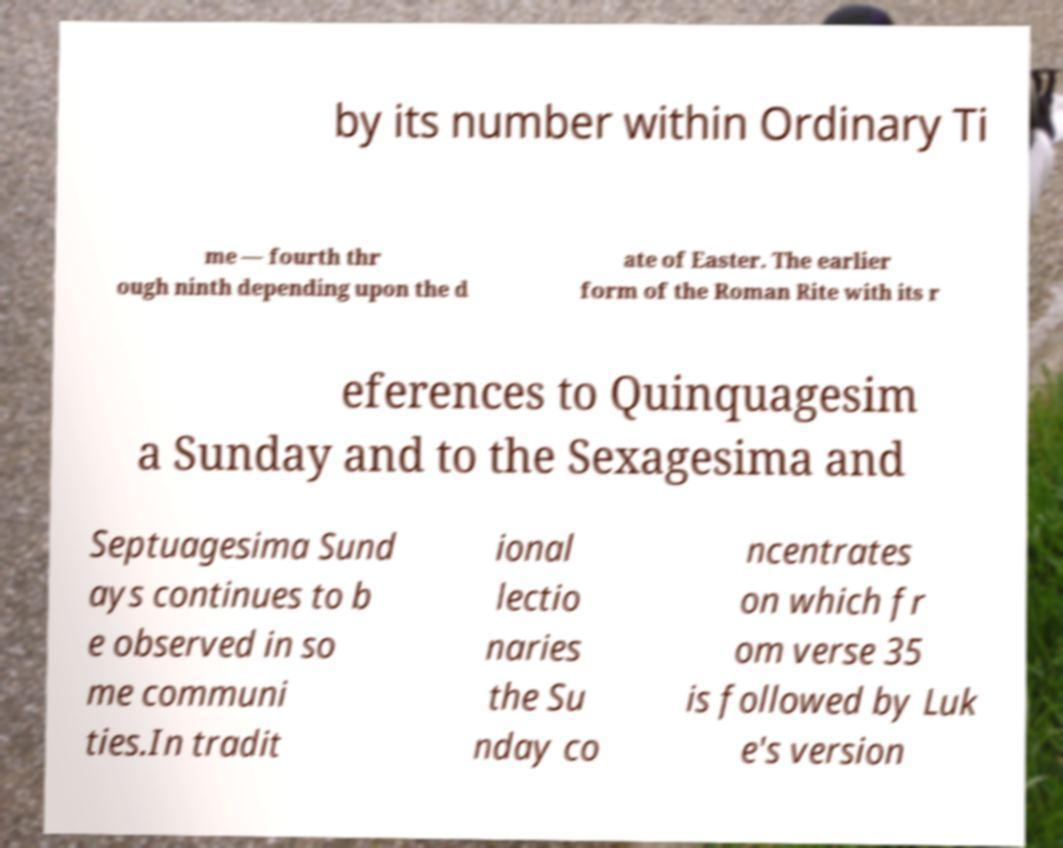What messages or text are displayed in this image? I need them in a readable, typed format. by its number within Ordinary Ti me — fourth thr ough ninth depending upon the d ate of Easter. The earlier form of the Roman Rite with its r eferences to Quinquagesim a Sunday and to the Sexagesima and Septuagesima Sund ays continues to b e observed in so me communi ties.In tradit ional lectio naries the Su nday co ncentrates on which fr om verse 35 is followed by Luk e's version 